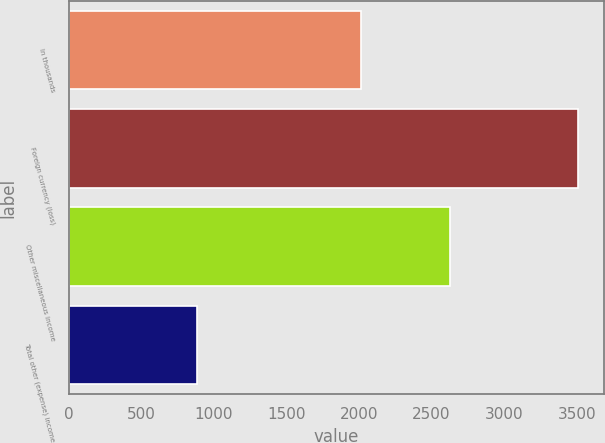Convert chart. <chart><loc_0><loc_0><loc_500><loc_500><bar_chart><fcel>In thousands<fcel>Foreign currency (loss)<fcel>Other miscellaneous income<fcel>Total other (expense) income<nl><fcel>2013<fcel>3512<fcel>2630<fcel>882<nl></chart> 